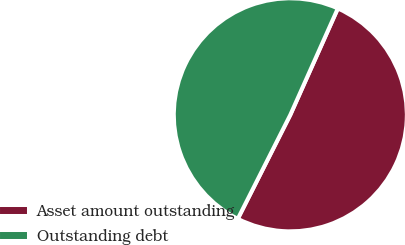Convert chart. <chart><loc_0><loc_0><loc_500><loc_500><pie_chart><fcel>Asset amount outstanding<fcel>Outstanding debt<nl><fcel>50.76%<fcel>49.24%<nl></chart> 